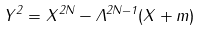<formula> <loc_0><loc_0><loc_500><loc_500>Y ^ { 2 } = X ^ { 2 N } - \Lambda ^ { 2 N - 1 } ( X + m )</formula> 